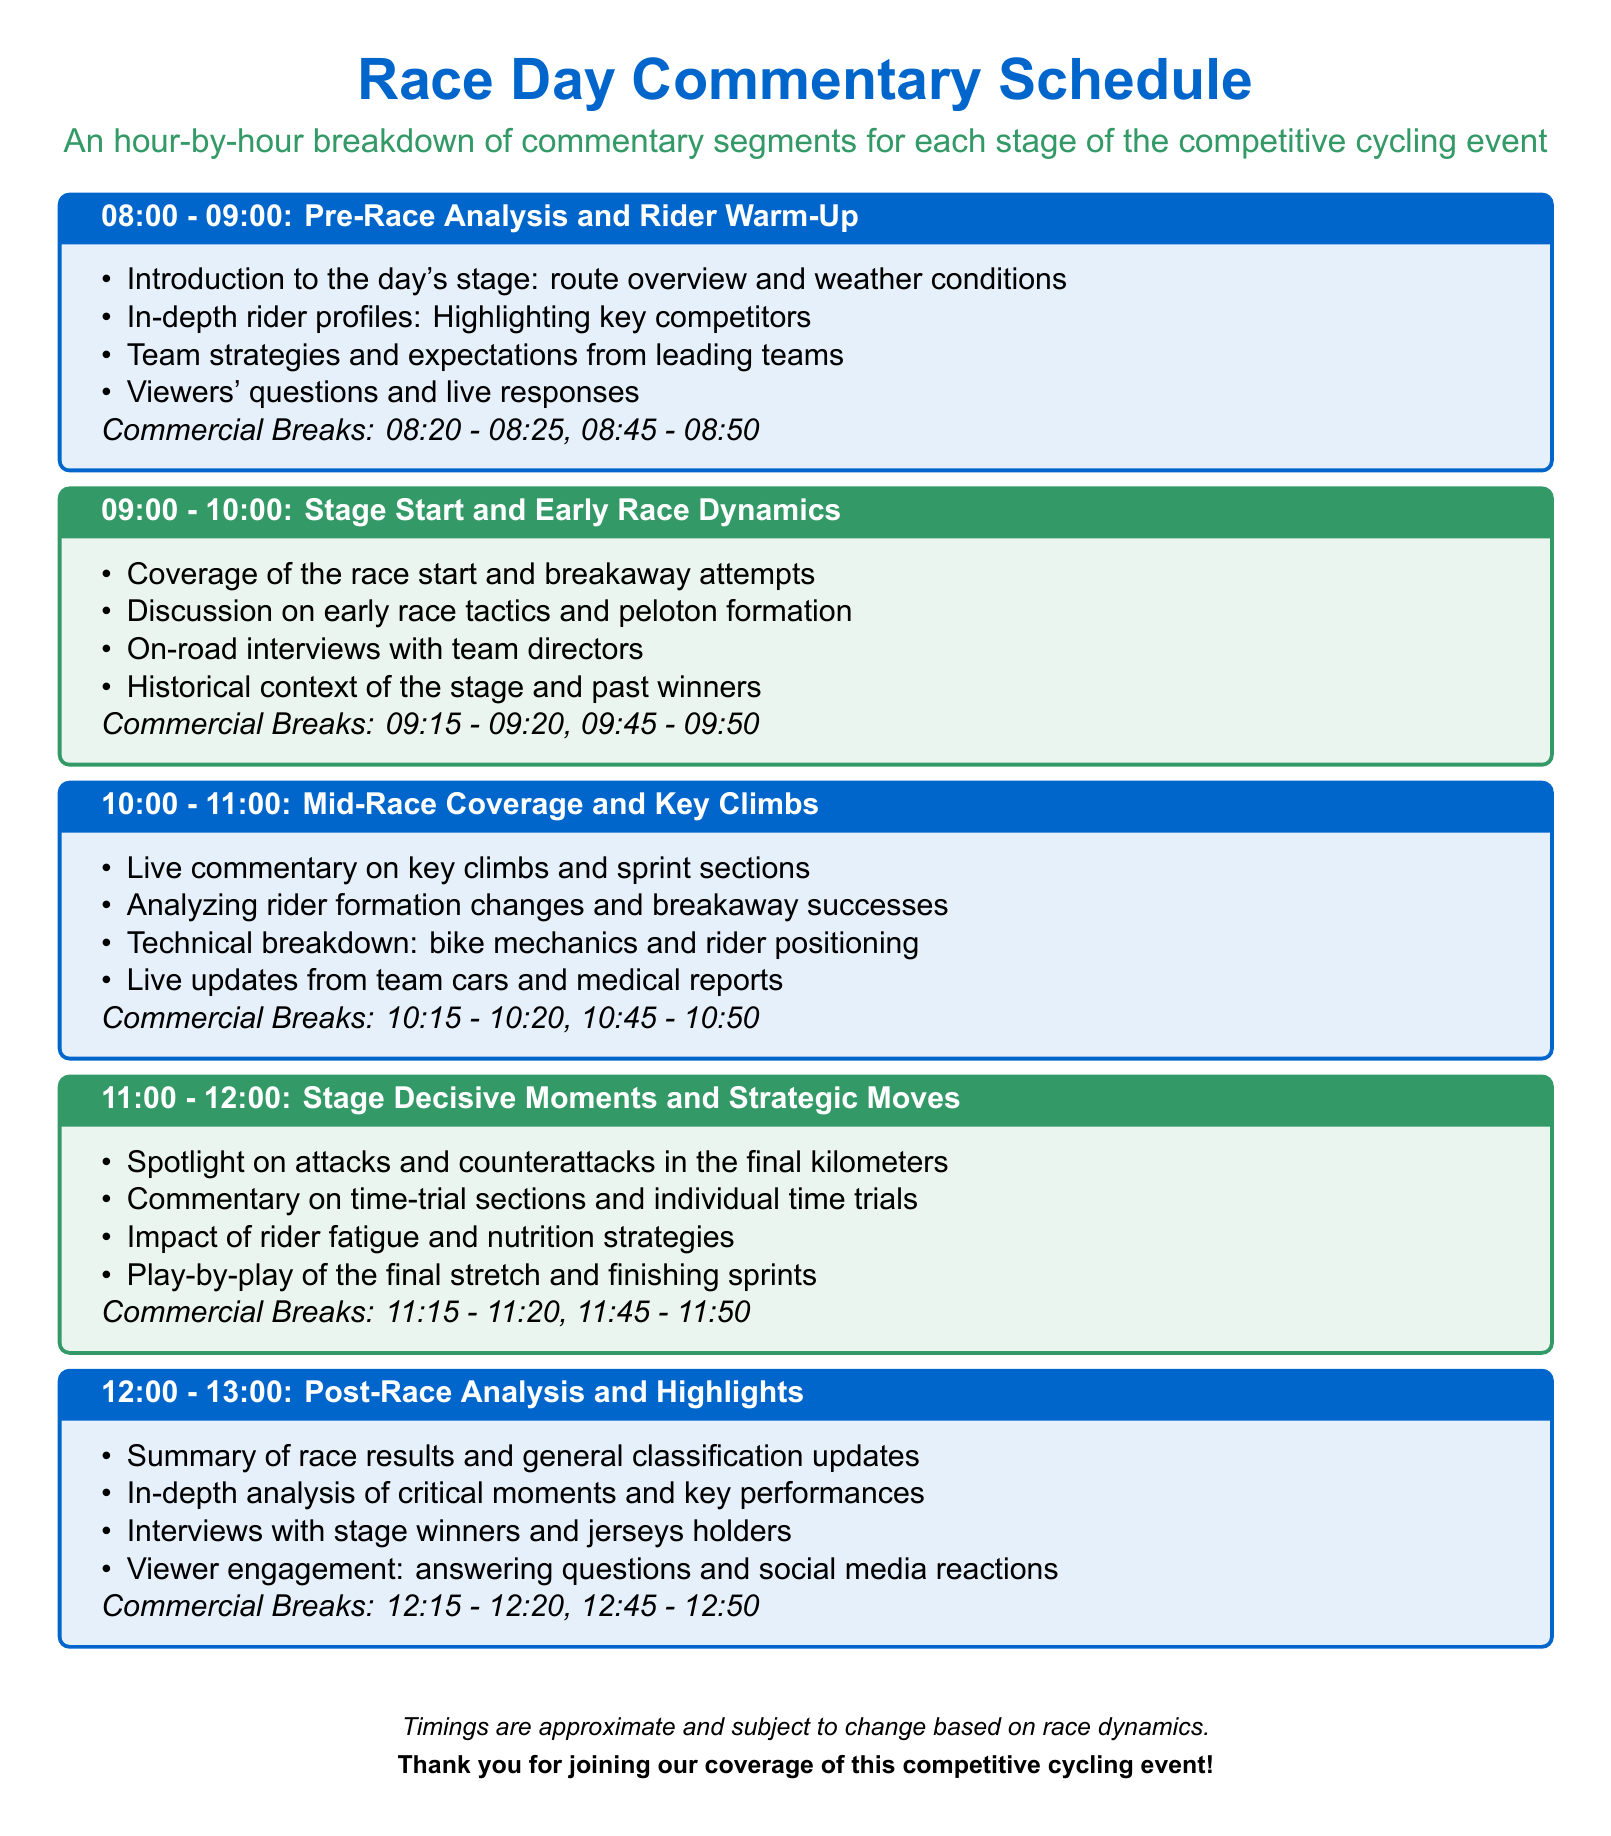What time does the pre-race analysis segment start? The pre-race analysis segment starts at 08:00.
Answer: 08:00 How many commercial breaks are there during the mid-race coverage? There are two commercial breaks during the mid-race coverage, listed in the corresponding box.
Answer: 2 What is discussed during the 11:00 to 12:00 segment? The 11:00 to 12:00 segment focuses on stage decisive moments and strategic moves.
Answer: Stage Decisive Moments and Strategic Moves At what time will the first commercial break occur during the stage start and early race dynamics? The first commercial break during this segment is scheduled for 09:15.
Answer: 09:15 What information is covered in the post-race analysis? The post-race analysis covers race results and general classification updates.
Answer: Race results and general classification updates Why are viewers' questions included in the pre-race analysis segment? Viewers' questions are included to engage the audience and provide real-time responses.
Answer: Audience engagement What is highlighted in the mid-race coverage? The mid-race coverage highlights key climbs and sprint sections.
Answer: Key climbs and sprint sections What is the content focus during the post-race analysis segment? The content focus during this segment includes critical moments and key performances.
Answer: Critical moments and key performances 